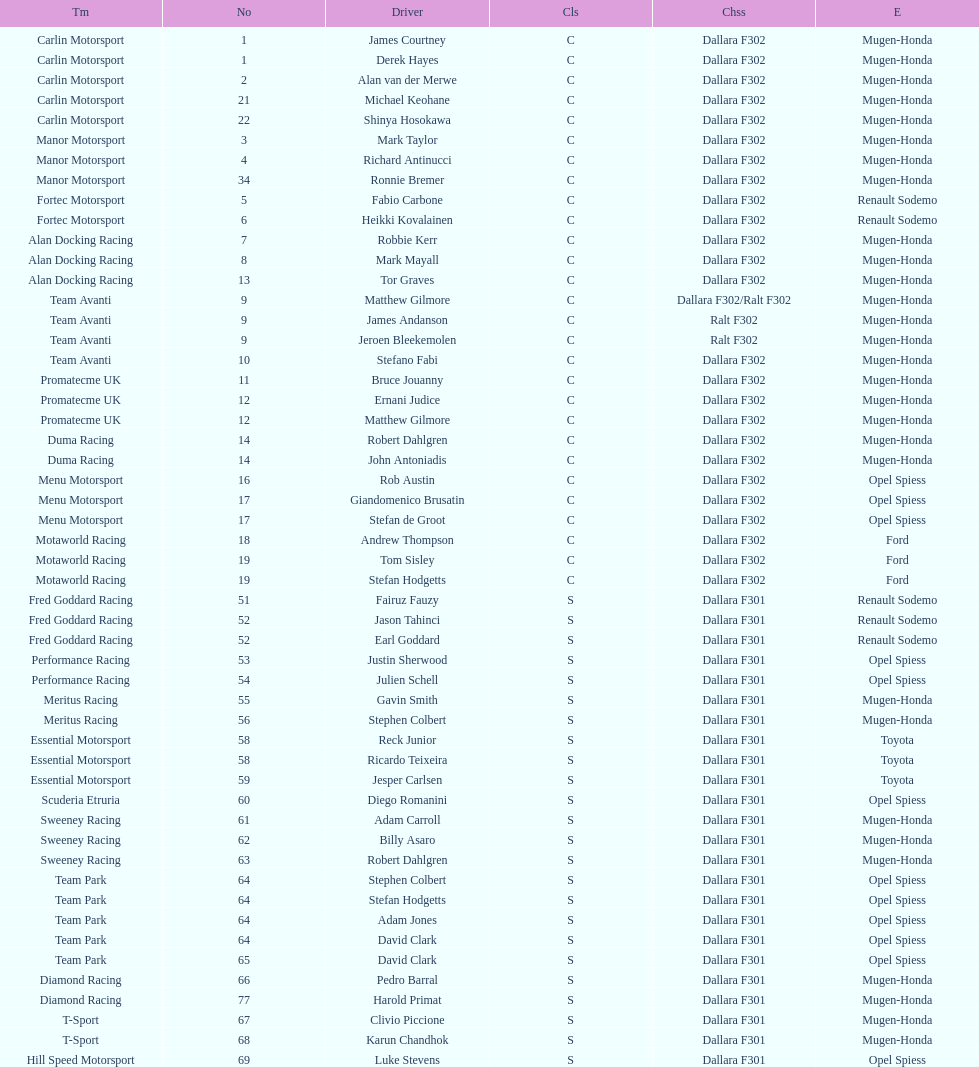How many class s (scholarship) teams are on the chart? 19. 